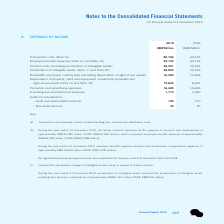According to Tencent's financial document, How much did the amortisation of intangible assets resulting from business combinations for year ended 31 December 2019 amount to? According to the financial document, RMB1,051 million. The relevant text states: "lting from business combinations of approximately RMB1,051 million (2018: RMB524 million)...." Also, How much was the share-based compensation expenses during the year ended 31 December 2019? According to the financial document, RMB10,500 million. The relevant text states: "approximately RMB10,500 million (2018: RMB7,900 million)...." Also, What did the transaction costs primarily consist of? bank handling fees, channel and distribution costs.. The document states: "(a) Transaction costs primarily consist of bank handling fees, channel and distribution costs...." Also, can you calculate: How much is the change in transaction costs from 2018 to 2019? Based on the calculation: 85,702-69,976, the result is 15726 (in millions). This is based on the information: "Transaction costs (Note (a)) 85,702 69,976 Transaction costs (Note (a)) 85,702 69,976..." The key data points involved are: 69,976, 85,702. Also, can you calculate: How much is the change in Employee benefits expenses from 2018 to 2019? Based on the calculation: 53,123-42,153, the result is 10970 (in millions). This is based on the information: "Employee benefits expenses (Note (b) and Note 13) 53,123 42,153 e benefits expenses (Note (b) and Note 13) 53,123 42,153..." The key data points involved are: 42,153, 53,123. Also, can you calculate: How much is the change in Promotion and advertising expenses from 2018 to 2019? Based on the calculation: 16,405-19,806, the result is -3401 (in millions). This is based on the information: "Promotion and advertising expenses 16,405 19,806 Promotion and advertising expenses 16,405 19,806..." The key data points involved are: 16,405, 19,806. 